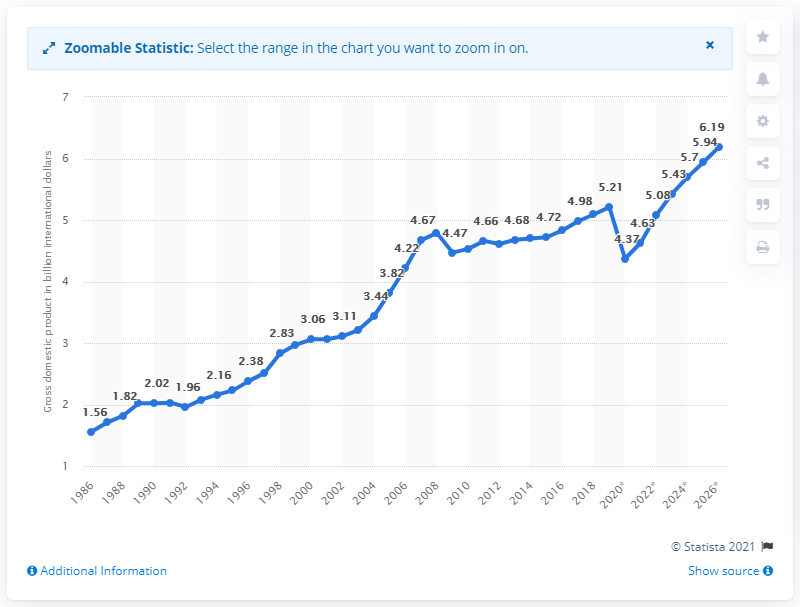Point out several critical features in this image. In 2019, the gross domestic product of Barbados was 5.21. 